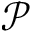Convert formula to latex. <formula><loc_0><loc_0><loc_500><loc_500>\mathcal { P }</formula> 